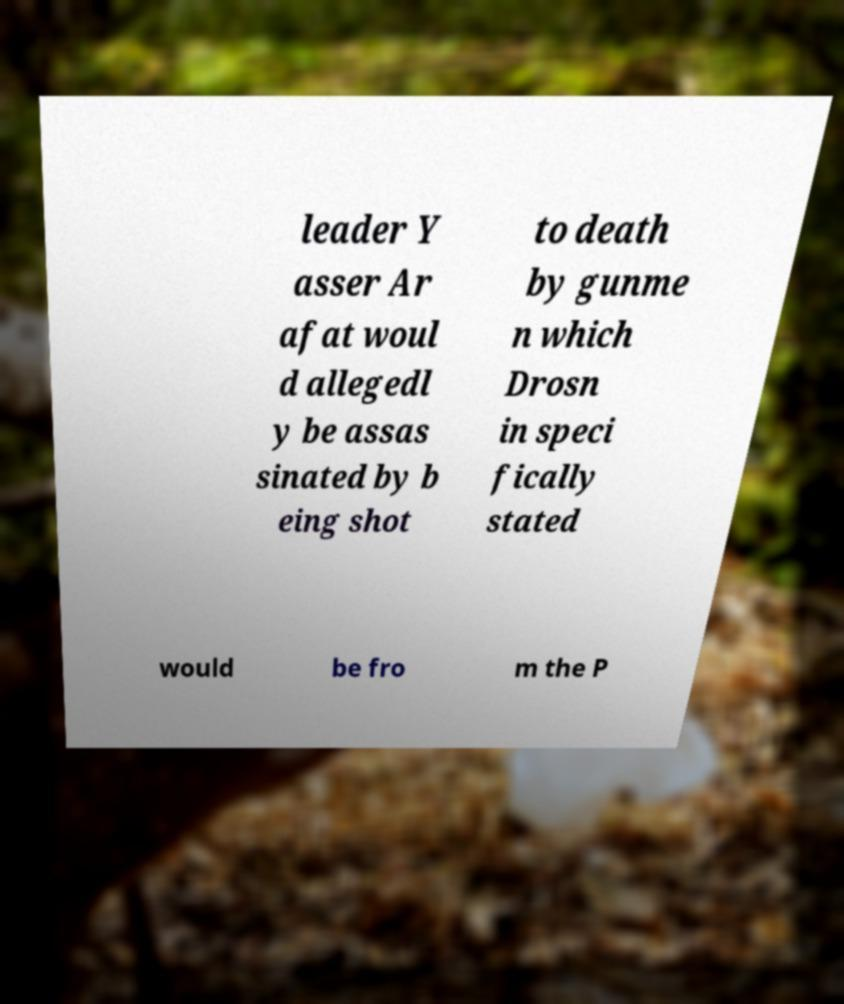Could you extract and type out the text from this image? leader Y asser Ar afat woul d allegedl y be assas sinated by b eing shot to death by gunme n which Drosn in speci fically stated would be fro m the P 